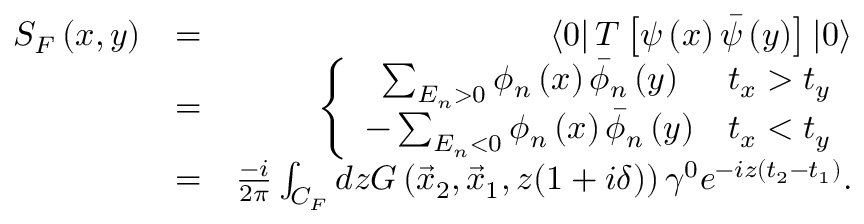Convert formula to latex. <formula><loc_0><loc_0><loc_500><loc_500>\begin{array} { r l r } { S _ { F } \left ( x , y \right ) } & { = } & { \left < 0 \right | T \left [ \psi \left ( x \right ) \bar { \psi } \left ( y \right ) \right ] \left | 0 \right > } \\ & { = } & { \left \{ \begin{array} { c c } { \sum _ { E _ { n } > 0 } \phi _ { n } \left ( x \right ) \bar { \phi } _ { n } \left ( y \right ) } & { t _ { x } > t _ { y } } \\ { - \sum _ { E _ { n } < 0 } \phi _ { n } \left ( x \right ) \bar { \phi } _ { n } \left ( y \right ) } & { t _ { x } < t _ { y } } \end{array} } \\ & { = } & { \frac { - i } { 2 \pi } \int _ { C _ { F } } d z G \left ( \vec { x } _ { 2 } , \vec { x } _ { 1 } , z ( 1 + i \delta ) \right ) \gamma ^ { 0 } e ^ { - i z \left ( t _ { 2 } - t _ { 1 } \right ) } . } \end{array}</formula> 